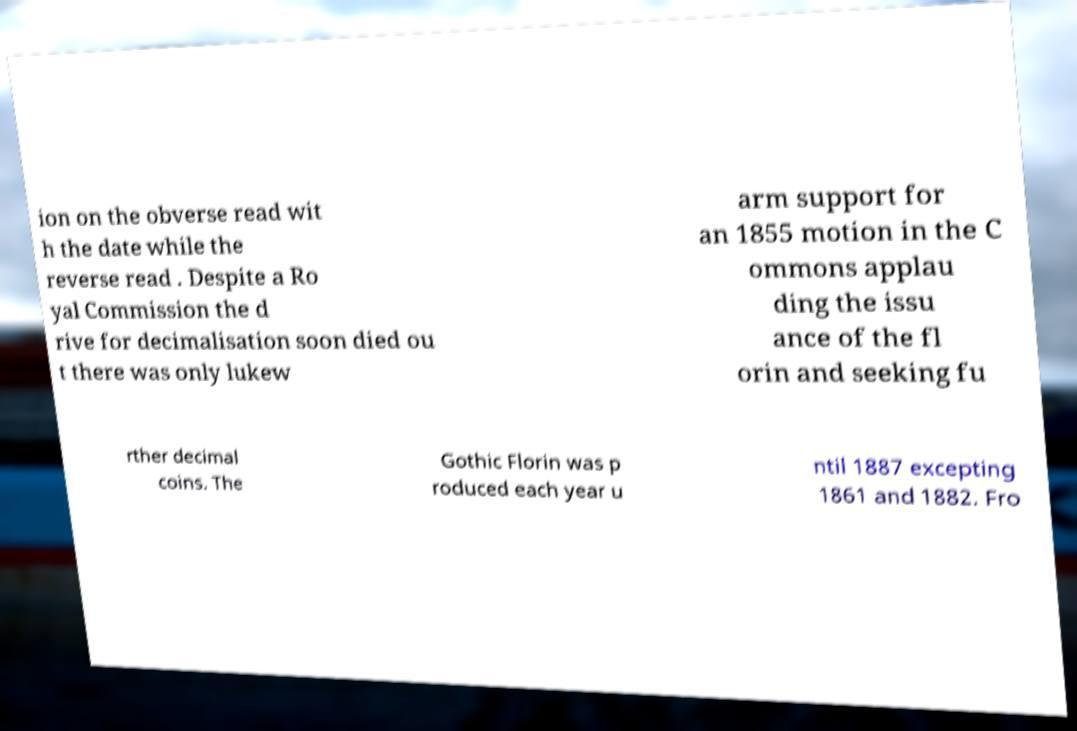For documentation purposes, I need the text within this image transcribed. Could you provide that? ion on the obverse read wit h the date while the reverse read . Despite a Ro yal Commission the d rive for decimalisation soon died ou t there was only lukew arm support for an 1855 motion in the C ommons applau ding the issu ance of the fl orin and seeking fu rther decimal coins. The Gothic Florin was p roduced each year u ntil 1887 excepting 1861 and 1882. Fro 